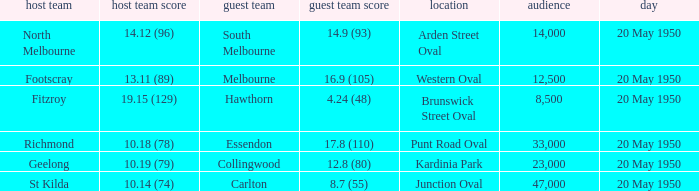What was the score for the away team when the home team was Fitzroy? 4.24 (48). 